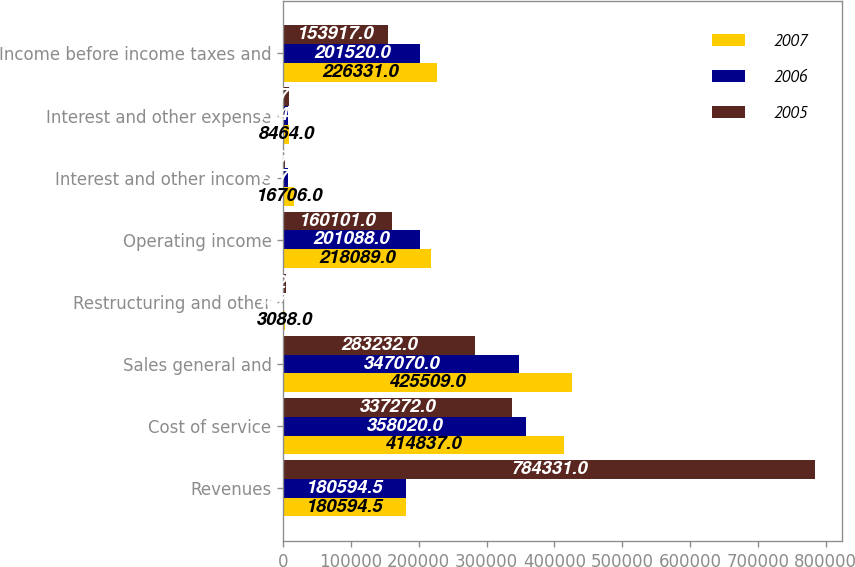Convert chart. <chart><loc_0><loc_0><loc_500><loc_500><stacked_bar_chart><ecel><fcel>Revenues<fcel>Cost of service<fcel>Sales general and<fcel>Restructuring and other<fcel>Operating income<fcel>Interest and other income<fcel>Interest and other expense<fcel>Income before income taxes and<nl><fcel>2007<fcel>180594<fcel>414837<fcel>425509<fcel>3088<fcel>218089<fcel>16706<fcel>8464<fcel>226331<nl><fcel>2006<fcel>180594<fcel>358020<fcel>347070<fcel>1878<fcel>201088<fcel>7576<fcel>7144<fcel>201520<nl><fcel>2005<fcel>784331<fcel>337272<fcel>283232<fcel>3726<fcel>160101<fcel>2194<fcel>8378<fcel>153917<nl></chart> 